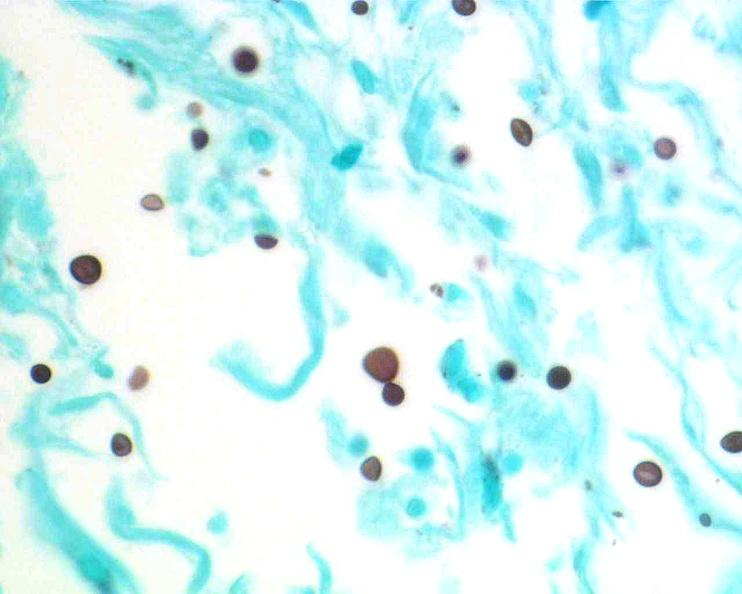what stain?
Answer the question using a single word or phrase. Gms 